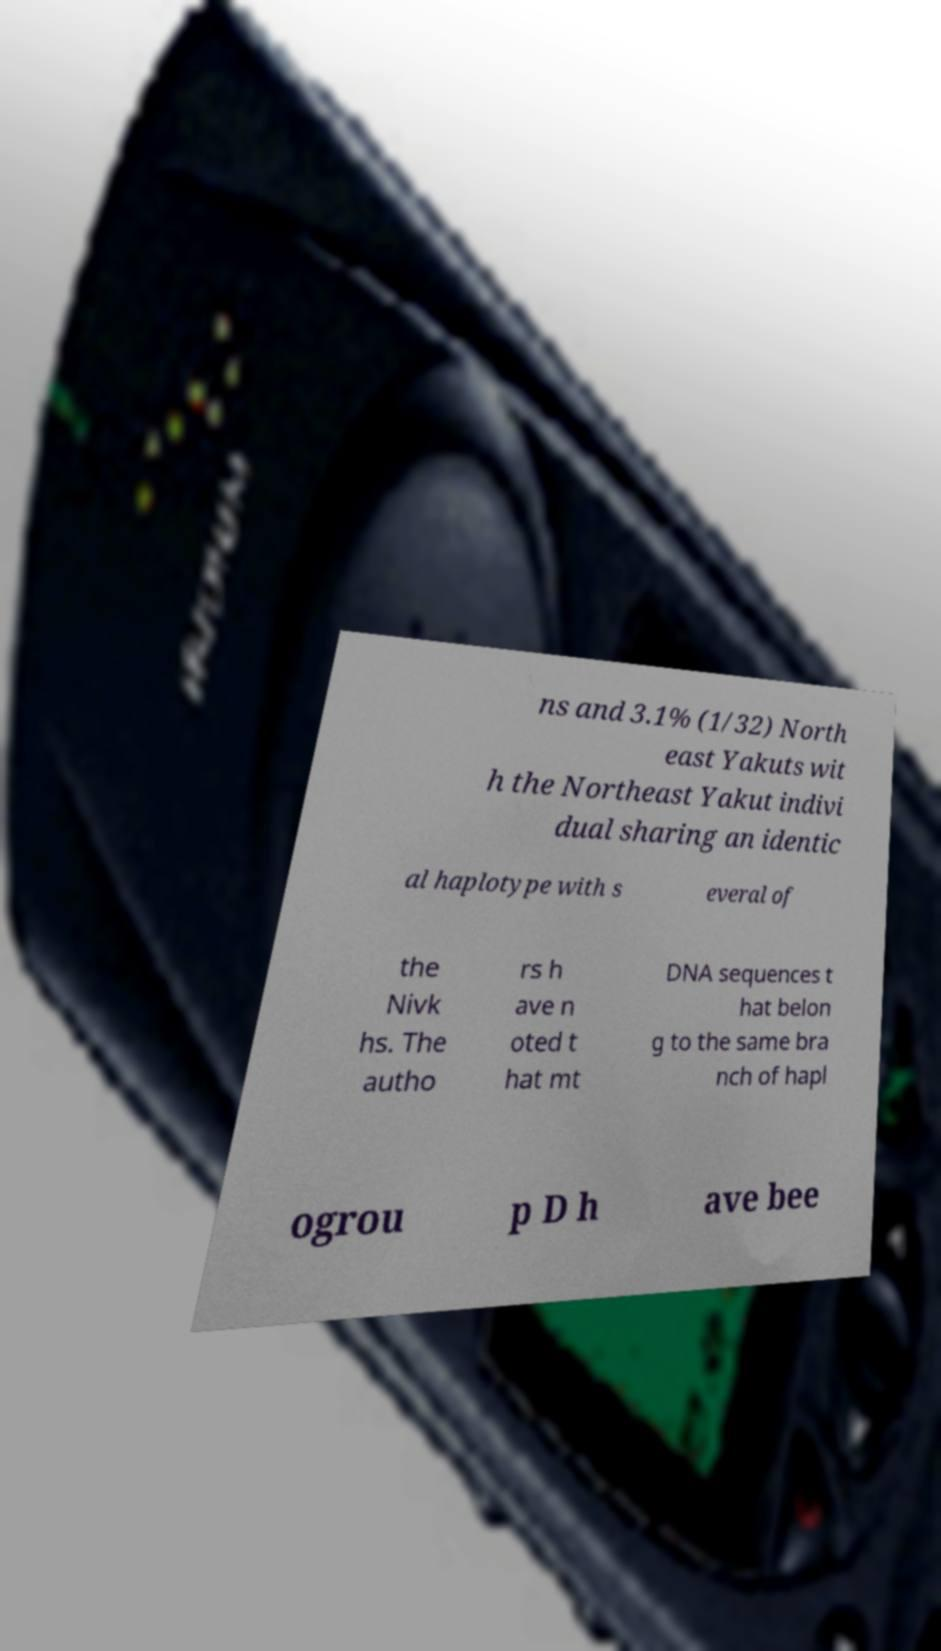Can you read and provide the text displayed in the image?This photo seems to have some interesting text. Can you extract and type it out for me? ns and 3.1% (1/32) North east Yakuts wit h the Northeast Yakut indivi dual sharing an identic al haplotype with s everal of the Nivk hs. The autho rs h ave n oted t hat mt DNA sequences t hat belon g to the same bra nch of hapl ogrou p D h ave bee 